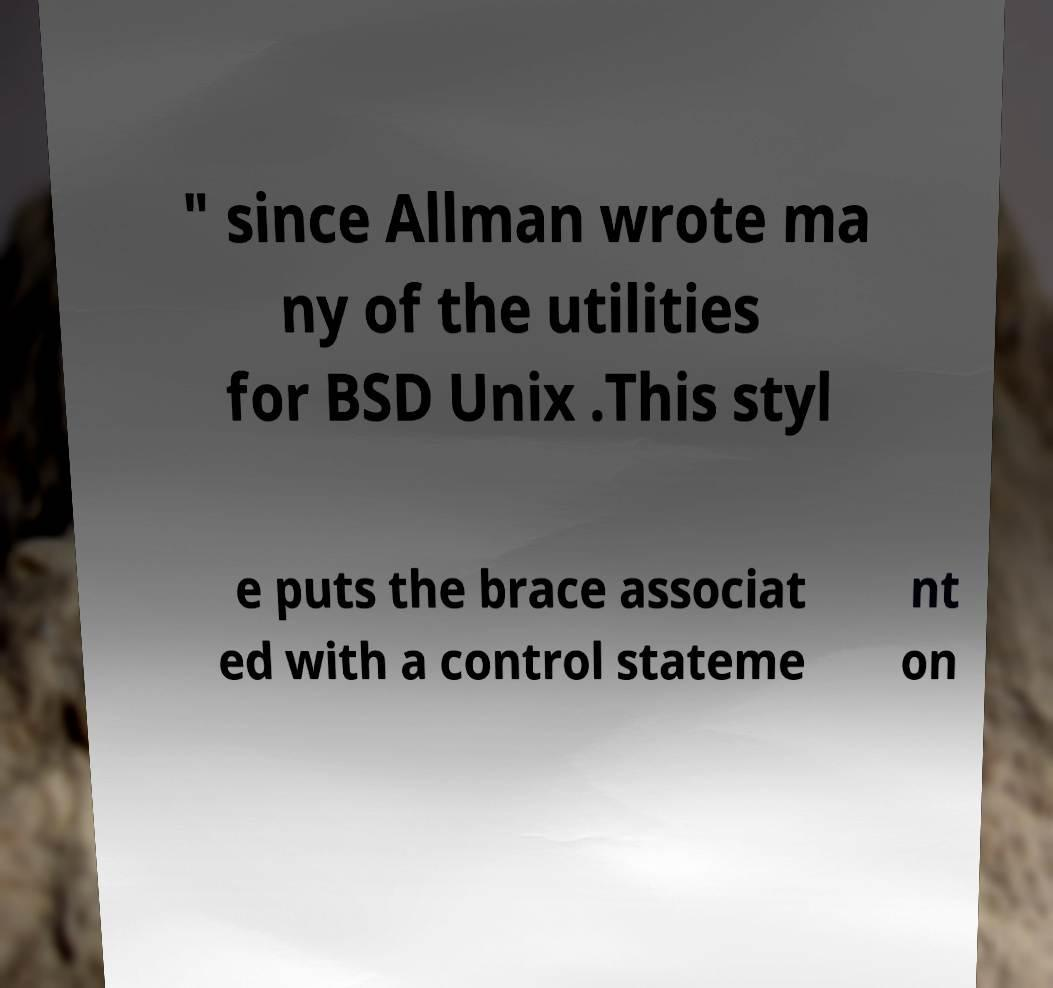Can you read and provide the text displayed in the image?This photo seems to have some interesting text. Can you extract and type it out for me? " since Allman wrote ma ny of the utilities for BSD Unix .This styl e puts the brace associat ed with a control stateme nt on 